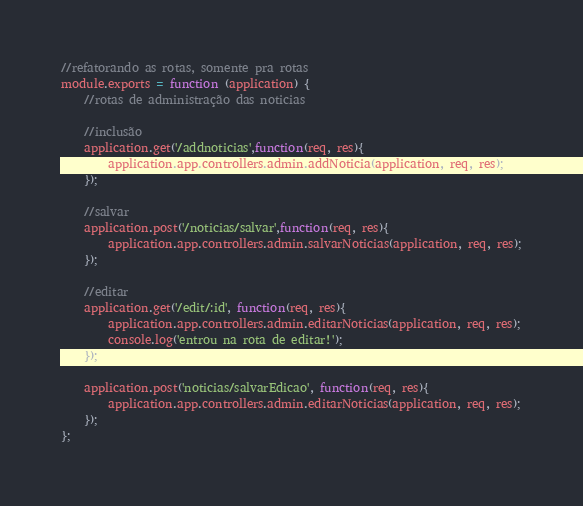<code> <loc_0><loc_0><loc_500><loc_500><_JavaScript_>//refatorando as rotas, somente pra rotas
module.exports = function (application) {
    //rotas de administração das noticias

    //inclusão    
    application.get('/addnoticias',function(req, res){
        application.app.controllers.admin.addNoticia(application, req, res);
    });

    //salvar
    application.post('/noticias/salvar',function(req, res){
        application.app.controllers.admin.salvarNoticias(application, req, res);
    });

    //editar
    application.get('/edit/:id', function(req, res){
        application.app.controllers.admin.editarNoticias(application, req, res);
        console.log('entrou na rota de editar!');
    });

    application.post('noticias/salvarEdicao', function(req, res){
        application.app.controllers.admin.editarNoticias(application, req, res);
    });
};</code> 